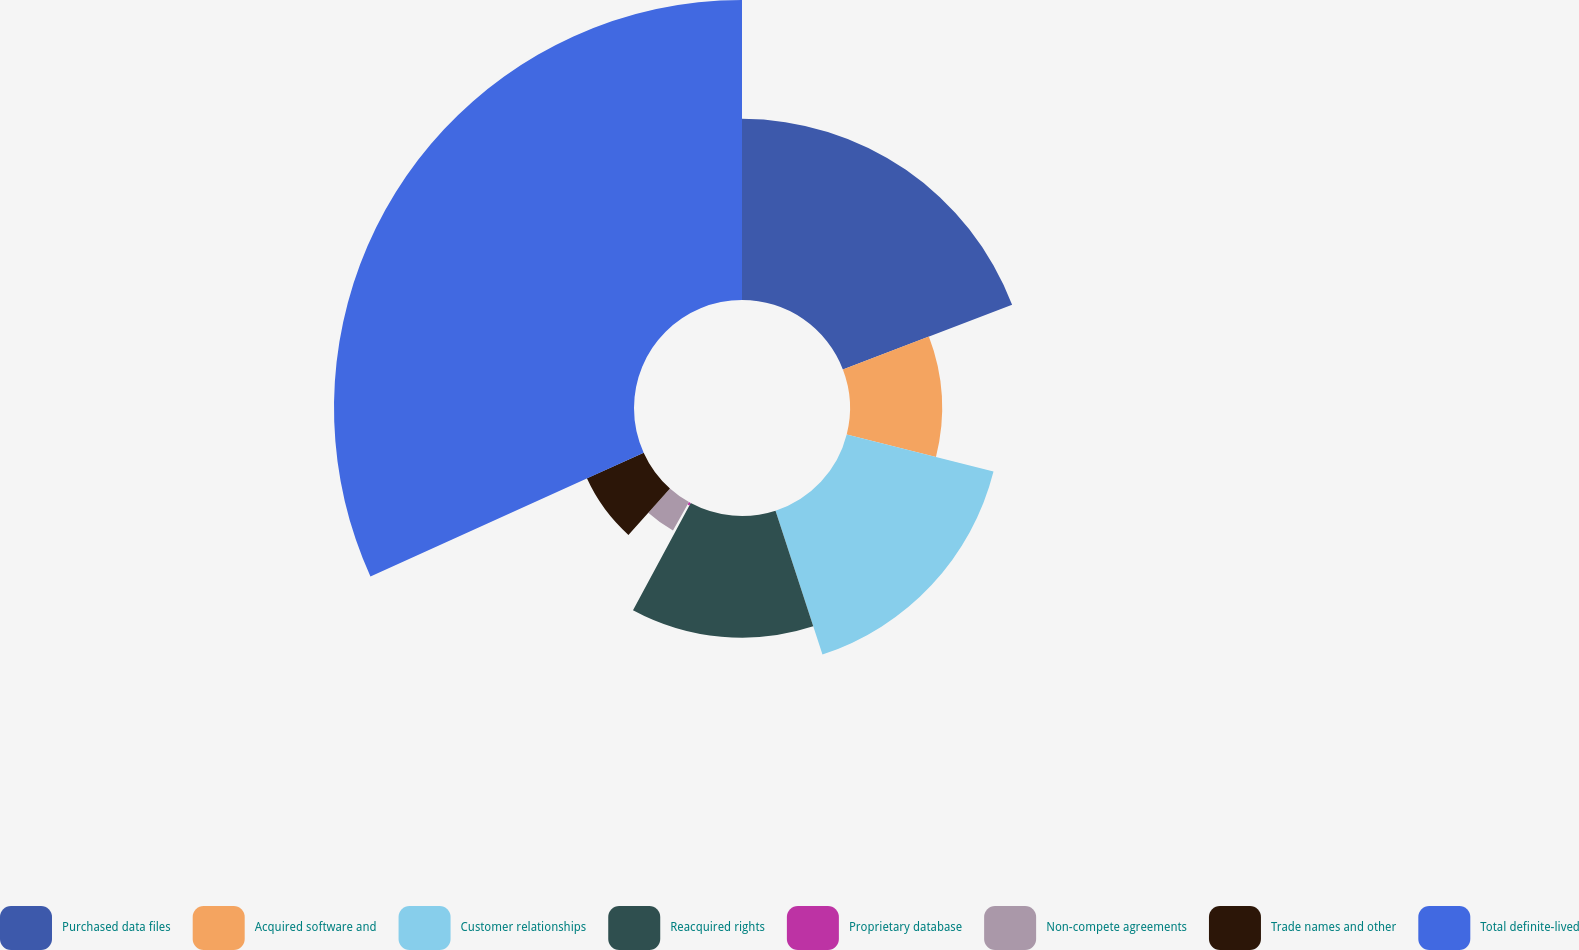<chart> <loc_0><loc_0><loc_500><loc_500><pie_chart><fcel>Purchased data files<fcel>Acquired software and<fcel>Customer relationships<fcel>Reacquired rights<fcel>Proprietary database<fcel>Non-compete agreements<fcel>Trade names and other<fcel>Total definite-lived<nl><fcel>19.19%<fcel>9.75%<fcel>16.04%<fcel>12.89%<fcel>0.3%<fcel>3.45%<fcel>6.6%<fcel>31.78%<nl></chart> 